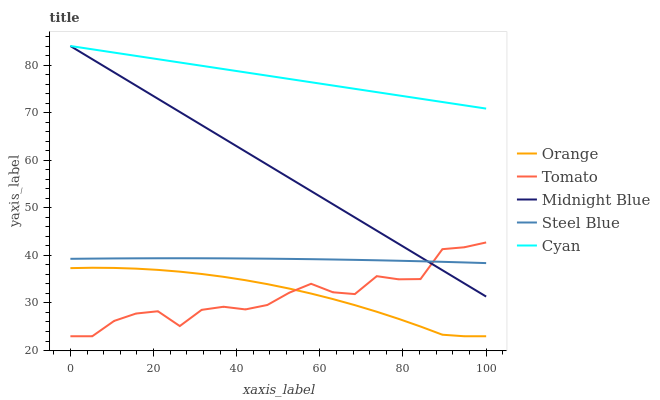Does Tomato have the minimum area under the curve?
Answer yes or no. Yes. Does Cyan have the maximum area under the curve?
Answer yes or no. Yes. Does Cyan have the minimum area under the curve?
Answer yes or no. No. Does Tomato have the maximum area under the curve?
Answer yes or no. No. Is Midnight Blue the smoothest?
Answer yes or no. Yes. Is Tomato the roughest?
Answer yes or no. Yes. Is Cyan the smoothest?
Answer yes or no. No. Is Cyan the roughest?
Answer yes or no. No. Does Orange have the lowest value?
Answer yes or no. Yes. Does Cyan have the lowest value?
Answer yes or no. No. Does Midnight Blue have the highest value?
Answer yes or no. Yes. Does Tomato have the highest value?
Answer yes or no. No. Is Steel Blue less than Cyan?
Answer yes or no. Yes. Is Cyan greater than Tomato?
Answer yes or no. Yes. Does Tomato intersect Orange?
Answer yes or no. Yes. Is Tomato less than Orange?
Answer yes or no. No. Is Tomato greater than Orange?
Answer yes or no. No. Does Steel Blue intersect Cyan?
Answer yes or no. No. 